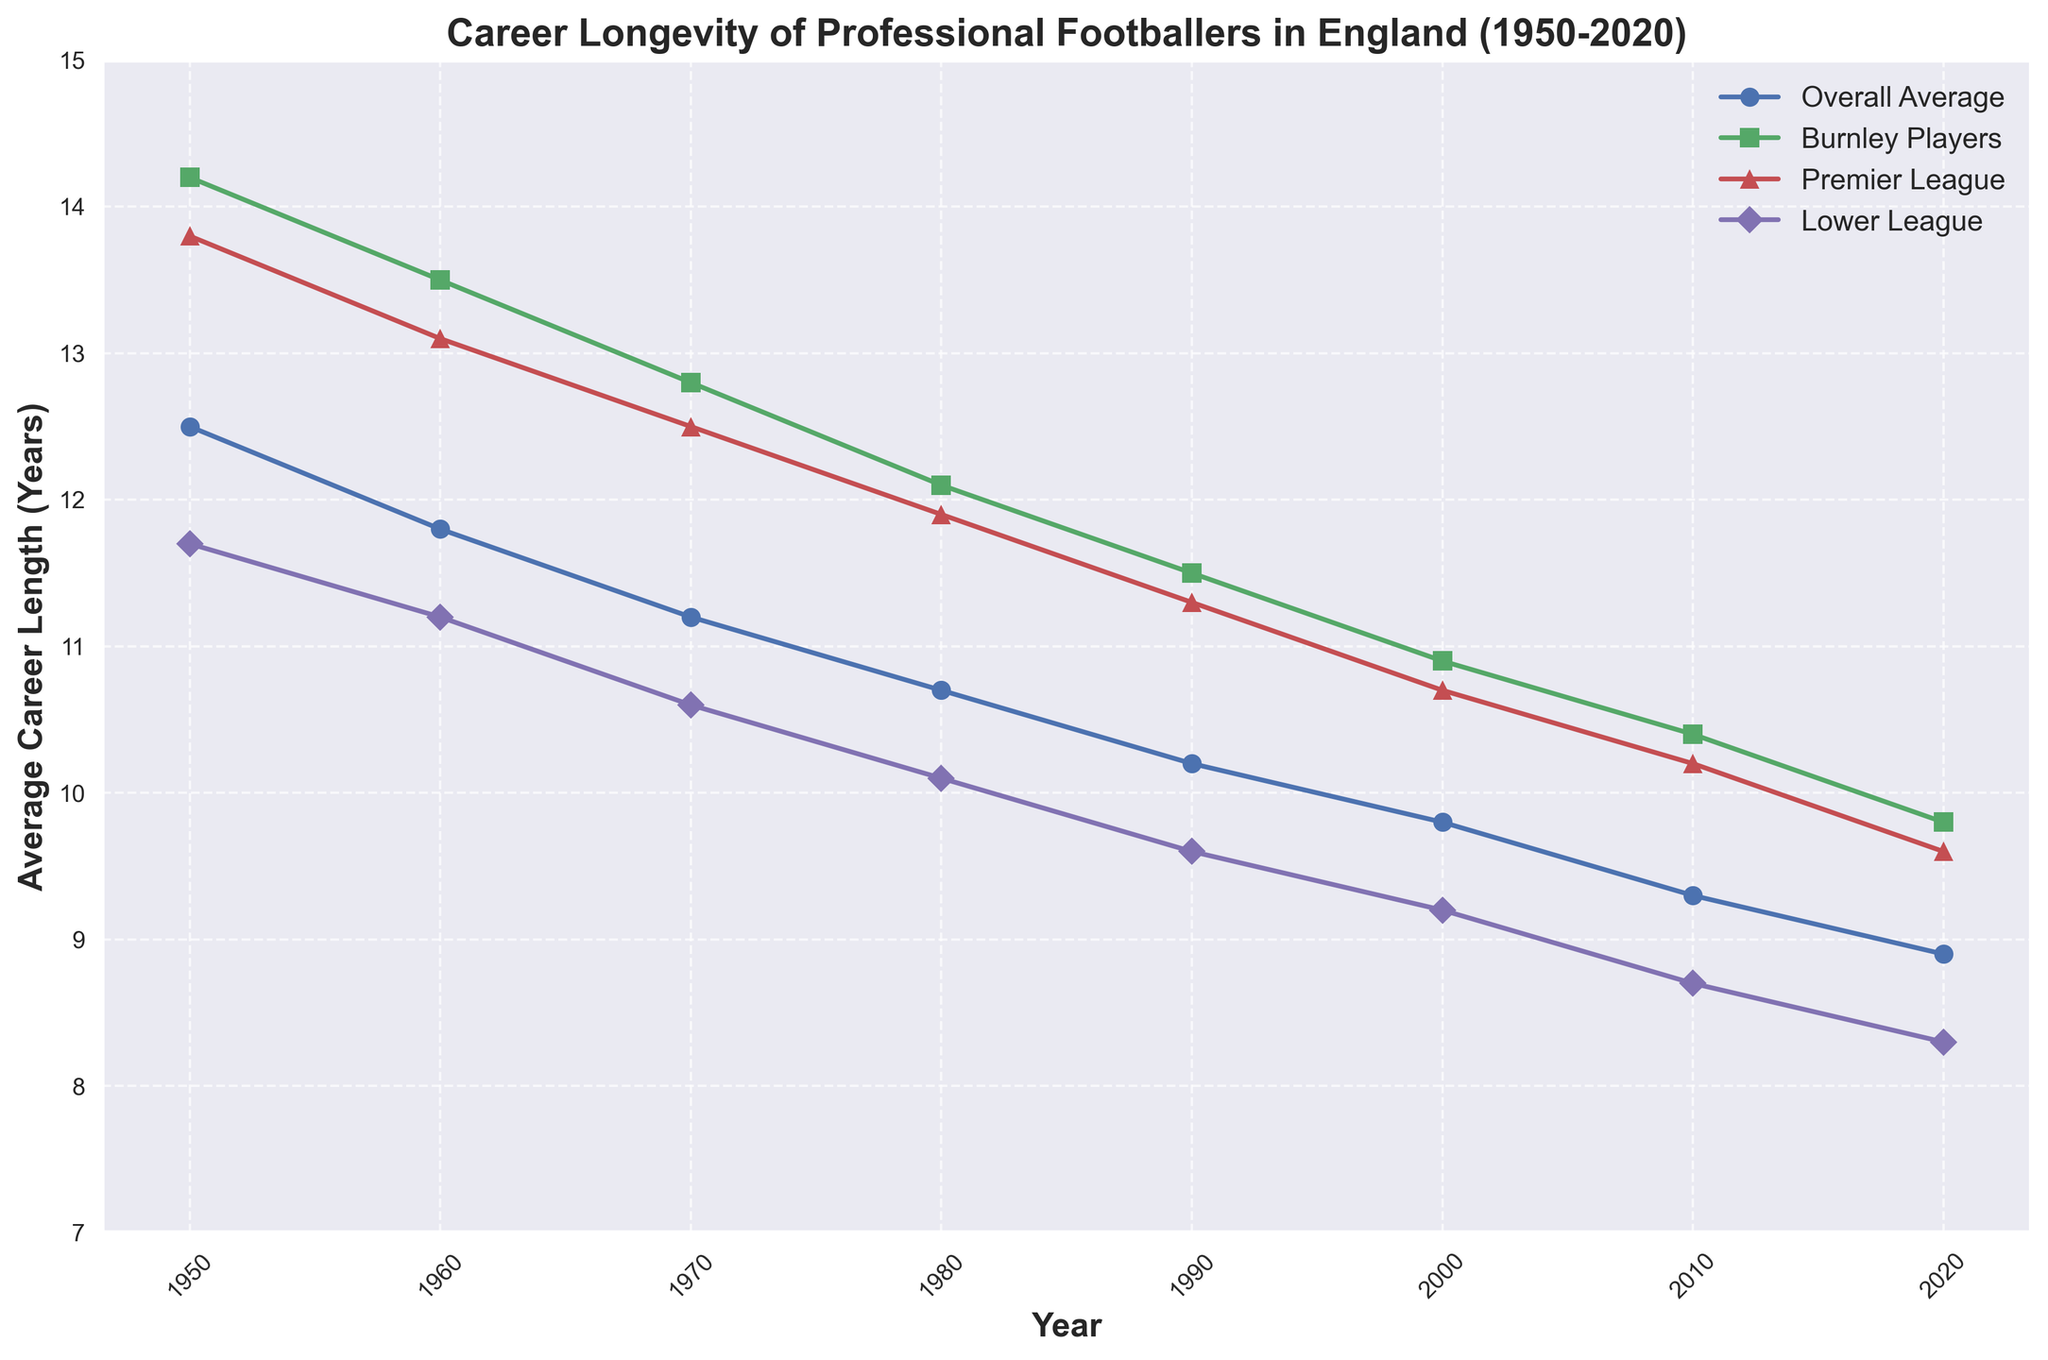What is the average career length of Burnley players in 1970? Look for the point on the line corresponding to Burnley players' average career length for the year 1970.
Answer: 12.8 years How does the average career length of lower league players in 2020 compare to that of Burnley players in 2020? Find the points for lower league players and Burnley players in 2020; the lower league is at 8.3 years, and Burnley is at 9.8 years.
Answer: Lower league is shorter What is the difference in career length between Burnley players and the overall average in 1950? Calculate the difference between Burnley's 14.2 years and the overall average of 12.5 years for 1950.
Answer: 1.7 years In which decade did the career length for Burnley players decrease the most? Examine the trend for Burnley players across decades and identify the largest decline, which happened between 1970 and 1980 (12.8 to 12.1 years).
Answer: 1970 to 1980 Compare the overall average career length trend from 1950 to 2020 with that of Burnley players; how does the trend differ? Both trends are downward, but Burnley players consistently have higher career lengths compared to the overall average.
Answer: Burnley players have a higher and decreasing trend How did Premier League players' average career length change from 1980 to 2020? Look at the points for Premier League players in 1980 (11.9 years) and 2020 (9.6 years) and calculate the change.
Answer: Decreased by 2.3 years What year shows the smallest difference between Burnley players' and lower league players' average career length? Compare the yearly data, noticing the smallest difference in 2020 (9.8 - 8.3 = 1.5 years).
Answer: 2020 What visual difference can you observe between the trend lines of Burnley players and lower league players from 1950 to 2020? Burnley players' trend line remains higher and shows a less steep decline compared to the steeper declining line of lower league players.
Answer: Higher and less steep What is the overall trend in average career length for all players from 1950 to 2020? The line representing the overall average career length shows a consistent downward trend from 12.5 years in 1950 to 8.9 years in 2020.
Answer: Consistently downward 